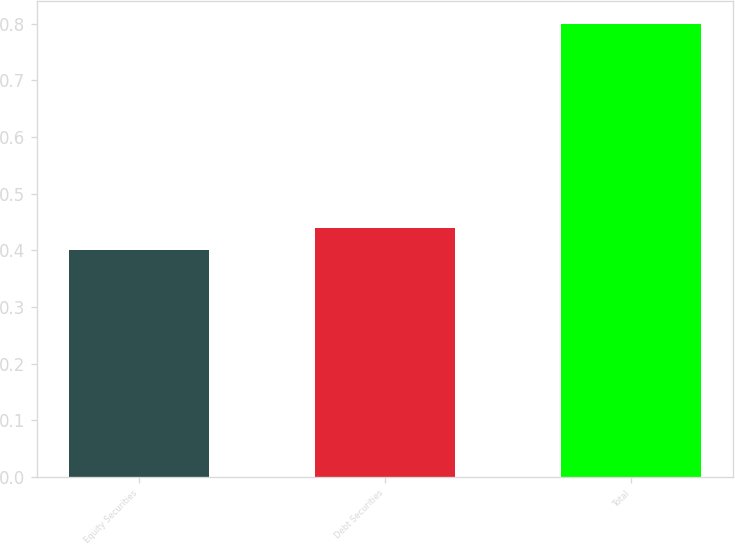<chart> <loc_0><loc_0><loc_500><loc_500><bar_chart><fcel>Equity Securities<fcel>Debt Securities<fcel>Total<nl><fcel>0.4<fcel>0.44<fcel>0.8<nl></chart> 